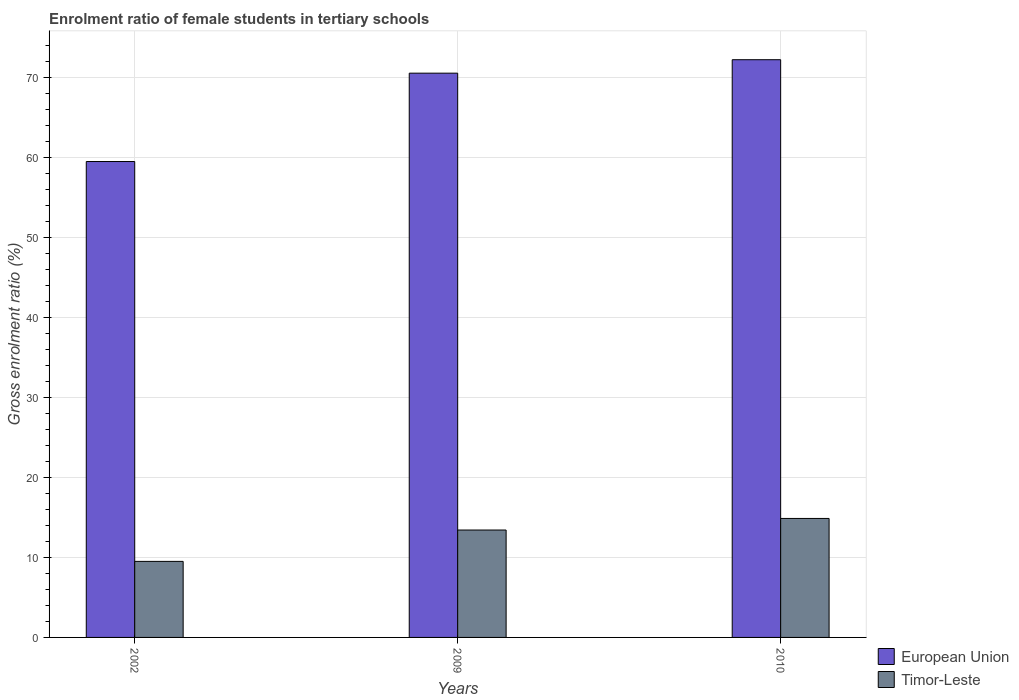How many different coloured bars are there?
Your answer should be compact. 2. How many bars are there on the 3rd tick from the left?
Give a very brief answer. 2. What is the enrolment ratio of female students in tertiary schools in European Union in 2010?
Your answer should be compact. 72.21. Across all years, what is the maximum enrolment ratio of female students in tertiary schools in Timor-Leste?
Provide a succinct answer. 14.87. Across all years, what is the minimum enrolment ratio of female students in tertiary schools in European Union?
Offer a terse response. 59.49. In which year was the enrolment ratio of female students in tertiary schools in Timor-Leste maximum?
Ensure brevity in your answer.  2010. What is the total enrolment ratio of female students in tertiary schools in Timor-Leste in the graph?
Provide a short and direct response. 37.8. What is the difference between the enrolment ratio of female students in tertiary schools in European Union in 2002 and that in 2009?
Keep it short and to the point. -11.04. What is the difference between the enrolment ratio of female students in tertiary schools in European Union in 2010 and the enrolment ratio of female students in tertiary schools in Timor-Leste in 2009?
Offer a terse response. 58.79. What is the average enrolment ratio of female students in tertiary schools in Timor-Leste per year?
Provide a short and direct response. 12.6. In the year 2010, what is the difference between the enrolment ratio of female students in tertiary schools in Timor-Leste and enrolment ratio of female students in tertiary schools in European Union?
Your answer should be very brief. -57.34. In how many years, is the enrolment ratio of female students in tertiary schools in Timor-Leste greater than 20 %?
Keep it short and to the point. 0. What is the ratio of the enrolment ratio of female students in tertiary schools in Timor-Leste in 2002 to that in 2009?
Make the answer very short. 0.71. Is the enrolment ratio of female students in tertiary schools in European Union in 2002 less than that in 2010?
Offer a very short reply. Yes. What is the difference between the highest and the second highest enrolment ratio of female students in tertiary schools in Timor-Leste?
Make the answer very short. 1.45. What is the difference between the highest and the lowest enrolment ratio of female students in tertiary schools in European Union?
Your answer should be very brief. 12.73. In how many years, is the enrolment ratio of female students in tertiary schools in European Union greater than the average enrolment ratio of female students in tertiary schools in European Union taken over all years?
Provide a short and direct response. 2. Is the sum of the enrolment ratio of female students in tertiary schools in Timor-Leste in 2002 and 2009 greater than the maximum enrolment ratio of female students in tertiary schools in European Union across all years?
Provide a short and direct response. No. What does the 2nd bar from the left in 2010 represents?
Offer a very short reply. Timor-Leste. What does the 2nd bar from the right in 2002 represents?
Make the answer very short. European Union. How many bars are there?
Your answer should be compact. 6. Are all the bars in the graph horizontal?
Offer a terse response. No. How many years are there in the graph?
Give a very brief answer. 3. What is the difference between two consecutive major ticks on the Y-axis?
Provide a short and direct response. 10. Does the graph contain any zero values?
Offer a terse response. No. Does the graph contain grids?
Your answer should be very brief. Yes. How many legend labels are there?
Offer a terse response. 2. How are the legend labels stacked?
Offer a very short reply. Vertical. What is the title of the graph?
Offer a very short reply. Enrolment ratio of female students in tertiary schools. Does "Mali" appear as one of the legend labels in the graph?
Provide a short and direct response. No. What is the label or title of the X-axis?
Give a very brief answer. Years. What is the Gross enrolment ratio (%) in European Union in 2002?
Offer a very short reply. 59.49. What is the Gross enrolment ratio (%) in Timor-Leste in 2002?
Make the answer very short. 9.5. What is the Gross enrolment ratio (%) of European Union in 2009?
Your answer should be very brief. 70.53. What is the Gross enrolment ratio (%) of Timor-Leste in 2009?
Your answer should be very brief. 13.42. What is the Gross enrolment ratio (%) in European Union in 2010?
Make the answer very short. 72.21. What is the Gross enrolment ratio (%) in Timor-Leste in 2010?
Your answer should be very brief. 14.87. Across all years, what is the maximum Gross enrolment ratio (%) in European Union?
Keep it short and to the point. 72.21. Across all years, what is the maximum Gross enrolment ratio (%) of Timor-Leste?
Ensure brevity in your answer.  14.87. Across all years, what is the minimum Gross enrolment ratio (%) of European Union?
Keep it short and to the point. 59.49. Across all years, what is the minimum Gross enrolment ratio (%) of Timor-Leste?
Your response must be concise. 9.5. What is the total Gross enrolment ratio (%) in European Union in the graph?
Make the answer very short. 202.23. What is the total Gross enrolment ratio (%) in Timor-Leste in the graph?
Keep it short and to the point. 37.8. What is the difference between the Gross enrolment ratio (%) of European Union in 2002 and that in 2009?
Your response must be concise. -11.04. What is the difference between the Gross enrolment ratio (%) of Timor-Leste in 2002 and that in 2009?
Ensure brevity in your answer.  -3.92. What is the difference between the Gross enrolment ratio (%) in European Union in 2002 and that in 2010?
Keep it short and to the point. -12.73. What is the difference between the Gross enrolment ratio (%) of Timor-Leste in 2002 and that in 2010?
Give a very brief answer. -5.37. What is the difference between the Gross enrolment ratio (%) of European Union in 2009 and that in 2010?
Make the answer very short. -1.68. What is the difference between the Gross enrolment ratio (%) in Timor-Leste in 2009 and that in 2010?
Offer a very short reply. -1.45. What is the difference between the Gross enrolment ratio (%) in European Union in 2002 and the Gross enrolment ratio (%) in Timor-Leste in 2009?
Your answer should be compact. 46.06. What is the difference between the Gross enrolment ratio (%) in European Union in 2002 and the Gross enrolment ratio (%) in Timor-Leste in 2010?
Provide a short and direct response. 44.62. What is the difference between the Gross enrolment ratio (%) in European Union in 2009 and the Gross enrolment ratio (%) in Timor-Leste in 2010?
Your response must be concise. 55.66. What is the average Gross enrolment ratio (%) in European Union per year?
Offer a terse response. 67.41. What is the average Gross enrolment ratio (%) in Timor-Leste per year?
Provide a short and direct response. 12.6. In the year 2002, what is the difference between the Gross enrolment ratio (%) in European Union and Gross enrolment ratio (%) in Timor-Leste?
Provide a short and direct response. 49.98. In the year 2009, what is the difference between the Gross enrolment ratio (%) in European Union and Gross enrolment ratio (%) in Timor-Leste?
Offer a terse response. 57.11. In the year 2010, what is the difference between the Gross enrolment ratio (%) of European Union and Gross enrolment ratio (%) of Timor-Leste?
Offer a very short reply. 57.34. What is the ratio of the Gross enrolment ratio (%) in European Union in 2002 to that in 2009?
Your answer should be very brief. 0.84. What is the ratio of the Gross enrolment ratio (%) in Timor-Leste in 2002 to that in 2009?
Your answer should be very brief. 0.71. What is the ratio of the Gross enrolment ratio (%) of European Union in 2002 to that in 2010?
Your response must be concise. 0.82. What is the ratio of the Gross enrolment ratio (%) in Timor-Leste in 2002 to that in 2010?
Keep it short and to the point. 0.64. What is the ratio of the Gross enrolment ratio (%) in European Union in 2009 to that in 2010?
Offer a very short reply. 0.98. What is the ratio of the Gross enrolment ratio (%) of Timor-Leste in 2009 to that in 2010?
Make the answer very short. 0.9. What is the difference between the highest and the second highest Gross enrolment ratio (%) of European Union?
Provide a succinct answer. 1.68. What is the difference between the highest and the second highest Gross enrolment ratio (%) of Timor-Leste?
Give a very brief answer. 1.45. What is the difference between the highest and the lowest Gross enrolment ratio (%) of European Union?
Offer a terse response. 12.73. What is the difference between the highest and the lowest Gross enrolment ratio (%) of Timor-Leste?
Provide a succinct answer. 5.37. 